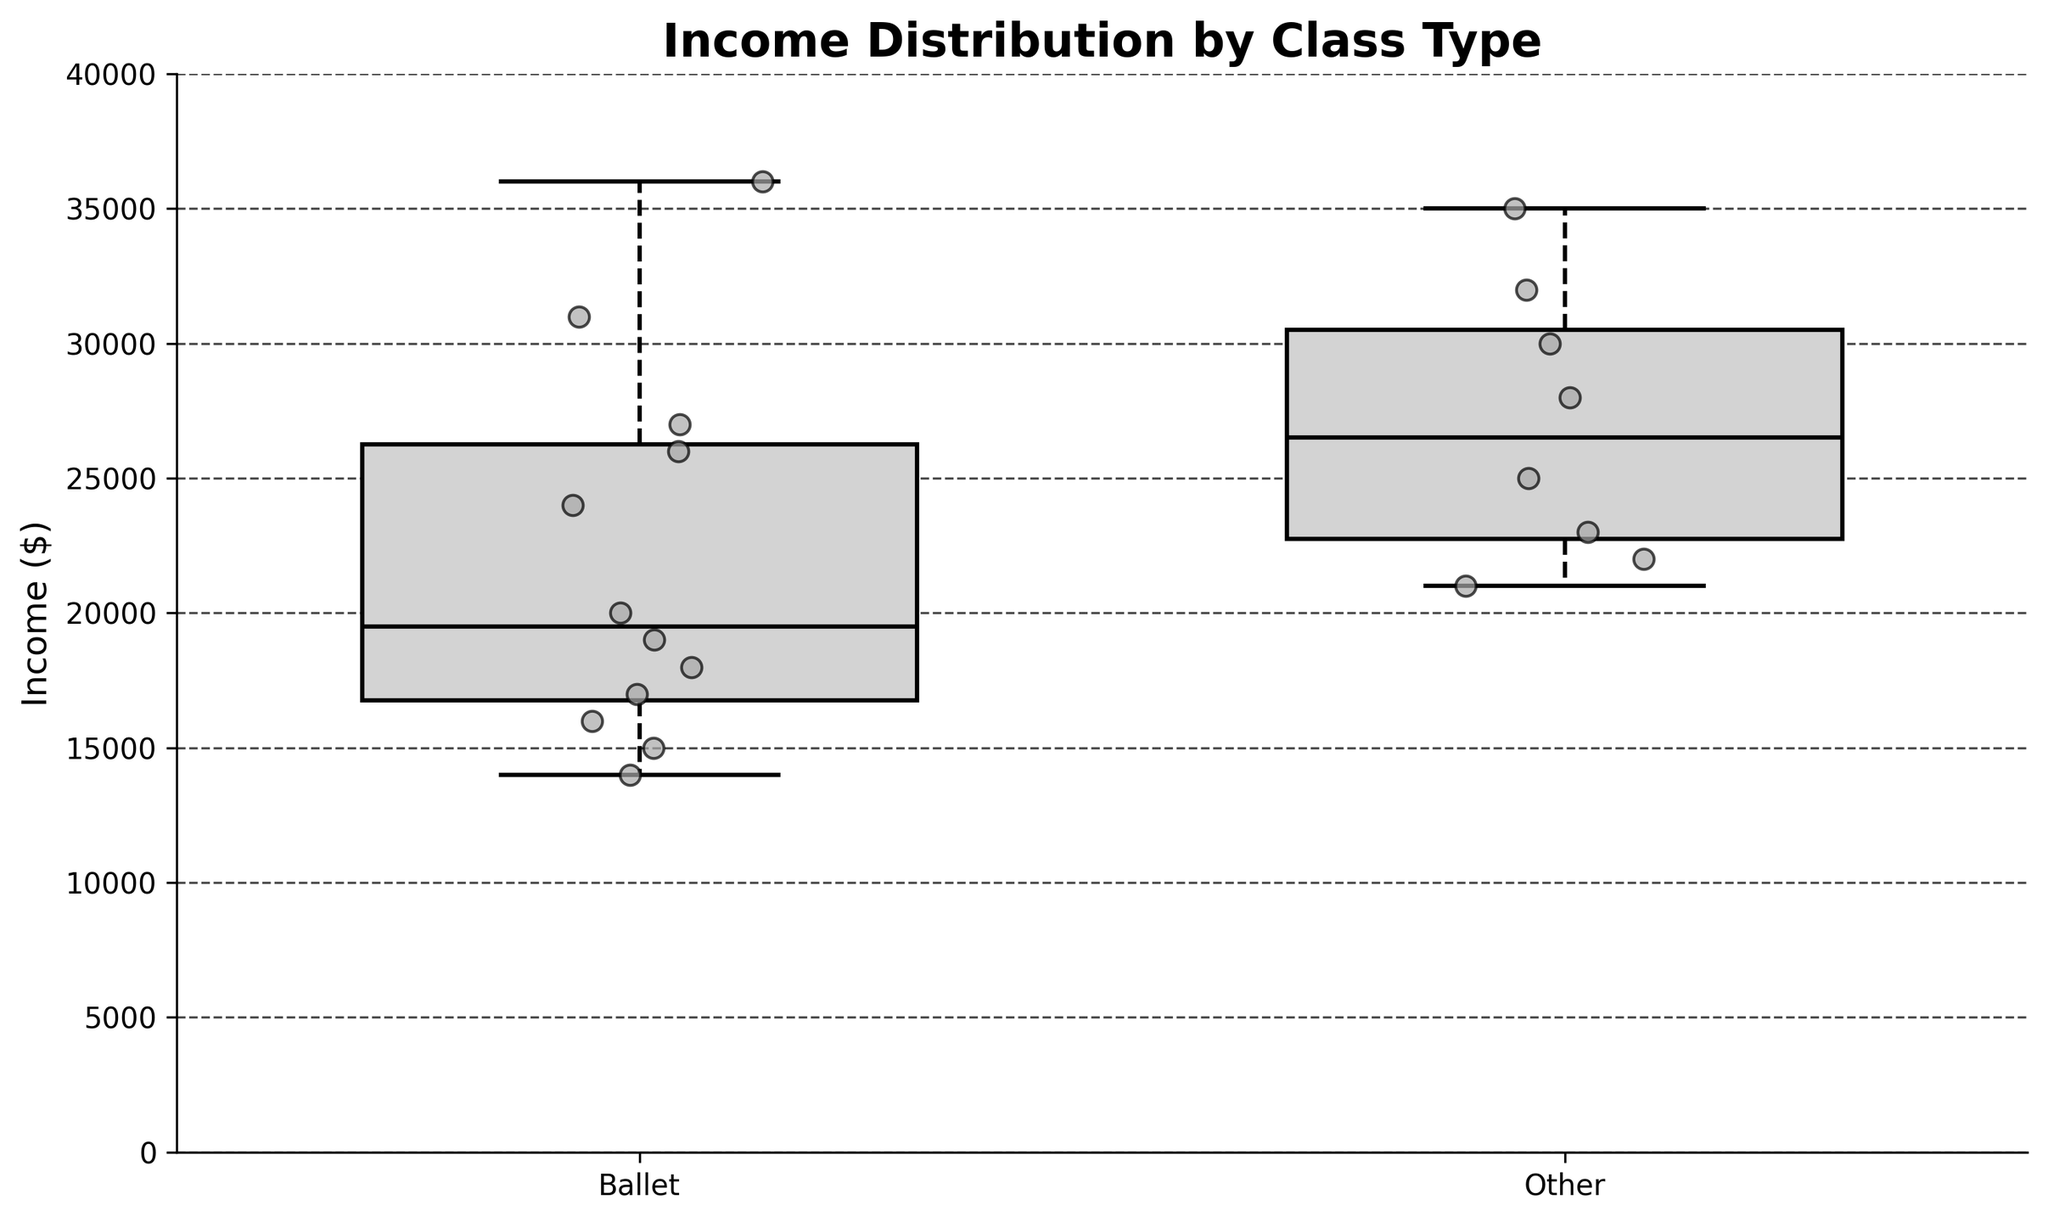What is the title of the figure? The title is written at the top of the figure in bold text.
Answer: Income Distribution by Class Type What are the labels on the x-axis? The x-axis labels are at the bottom of the figure, representing the categories of class types.
Answer: Ballet, Other What is the y-axis showing? The y-axis displays the numerical range of the variable being measured, which is indicated by the label.
Answer: Income ($) What is the median income for families attending ballet classes? The median is shown by the middle line within the box of the Ballet category.
Answer: $20000 Are there any families in the 'Ballet' category with an income above $35000? Scatter points above the upper whisker of the Ballet box indicate income outliers. There are no points above $35000 for the Ballet category.
Answer: No Which class type appears to have a wider income spread? The spread can be assessed by looking at the range of the whiskers in the box plots.
Answer: Ballet What is the interquartile range (IQR) for the Ballet income? The IQR is the range between the first quartile (lower box edge) and the third quartile (upper box edge) of the Ballet box plot.
Answer: $11000 ($25000 - $14000) Which group has the highest outlier in terms of income and what is the value? The highest outlier is indicated by the scattered point furthest from the box plot.
Answer: Contemporary, $36000 On average, do families attending ballet classes have higher or lower income compared to those attending other class types? This can be assessed by comparing the height of the median lines in each box plot.
Answer: Lower How many data points are included in the Ballet category? Each scatter point represents a data point; count the number of points in the Ballet category.
Answer: 11 